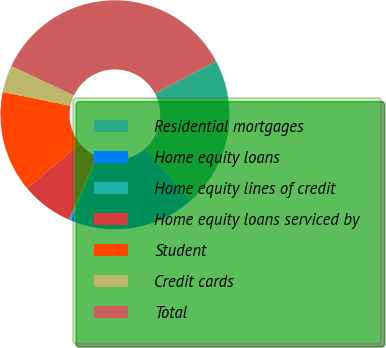<chart> <loc_0><loc_0><loc_500><loc_500><pie_chart><fcel>Residential mortgages<fcel>Home equity loans<fcel>Home equity lines of credit<fcel>Home equity loans serviced by<fcel>Student<fcel>Credit cards<fcel>Total<nl><fcel>21.27%<fcel>17.78%<fcel>0.32%<fcel>7.3%<fcel>14.29%<fcel>3.81%<fcel>35.23%<nl></chart> 